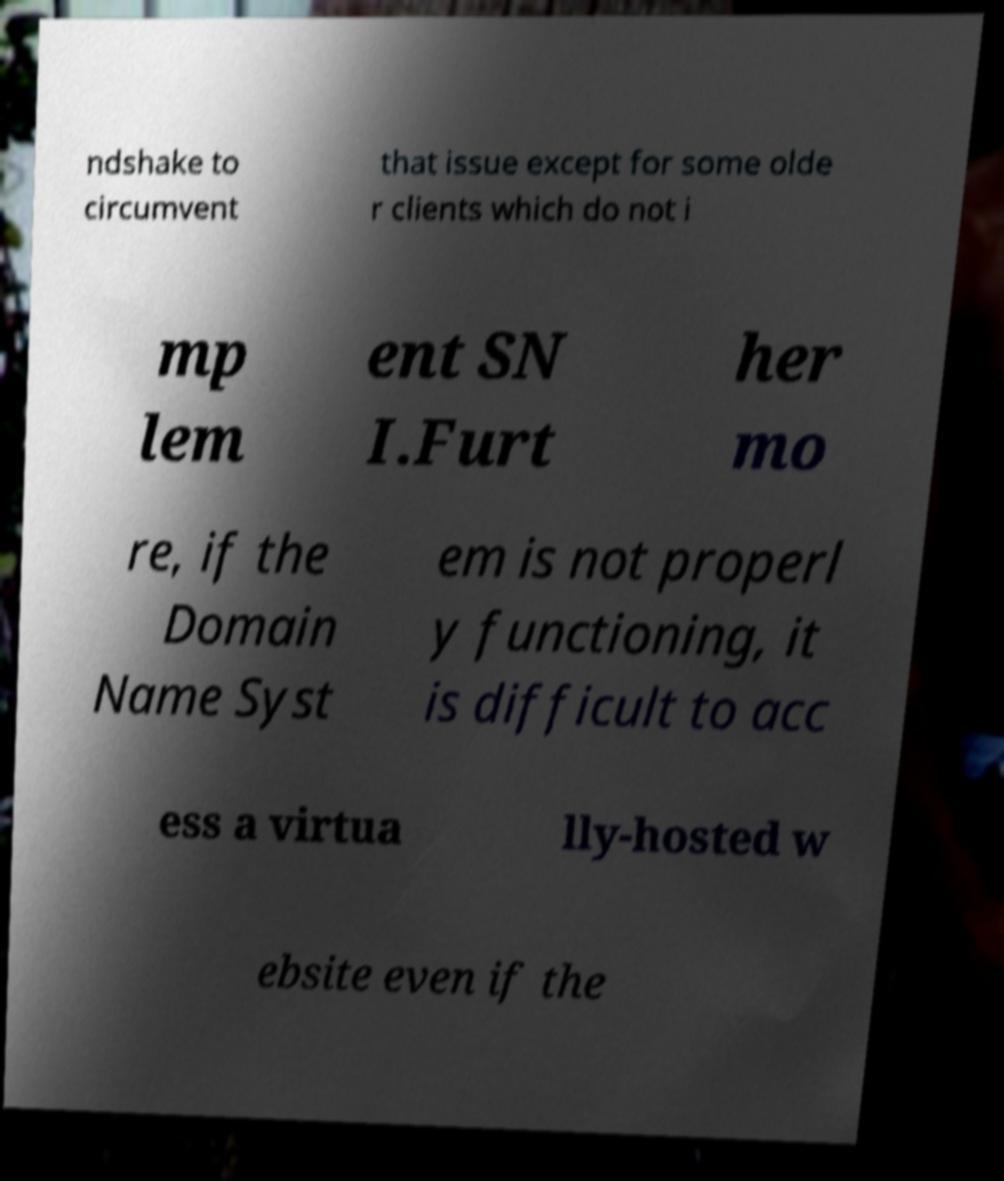For documentation purposes, I need the text within this image transcribed. Could you provide that? ndshake to circumvent that issue except for some olde r clients which do not i mp lem ent SN I.Furt her mo re, if the Domain Name Syst em is not properl y functioning, it is difficult to acc ess a virtua lly-hosted w ebsite even if the 